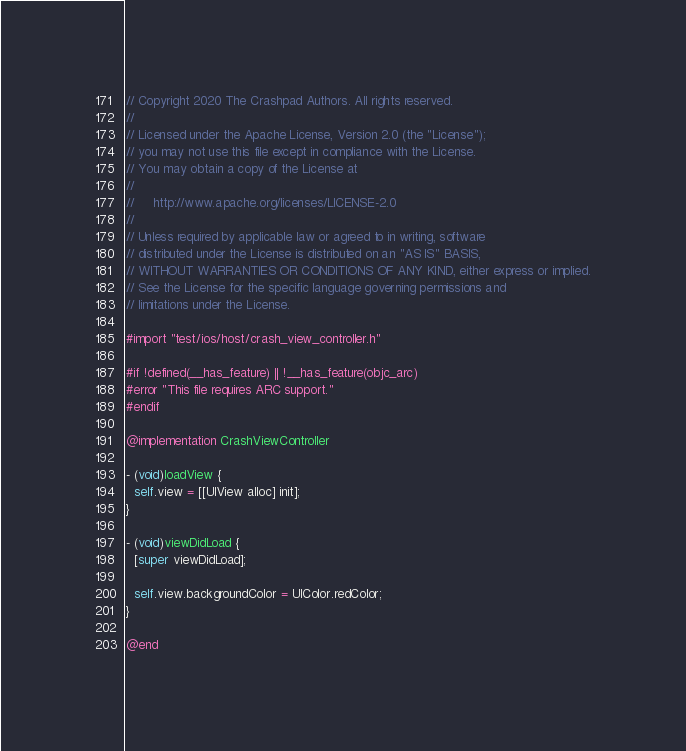<code> <loc_0><loc_0><loc_500><loc_500><_ObjectiveC_>// Copyright 2020 The Crashpad Authors. All rights reserved.
//
// Licensed under the Apache License, Version 2.0 (the "License");
// you may not use this file except in compliance with the License.
// You may obtain a copy of the License at
//
//     http://www.apache.org/licenses/LICENSE-2.0
//
// Unless required by applicable law or agreed to in writing, software
// distributed under the License is distributed on an "AS IS" BASIS,
// WITHOUT WARRANTIES OR CONDITIONS OF ANY KIND, either express or implied.
// See the License for the specific language governing permissions and
// limitations under the License.

#import "test/ios/host/crash_view_controller.h"

#if !defined(__has_feature) || !__has_feature(objc_arc)
#error "This file requires ARC support."
#endif

@implementation CrashViewController

- (void)loadView {
  self.view = [[UIView alloc] init];
}

- (void)viewDidLoad {
  [super viewDidLoad];

  self.view.backgroundColor = UIColor.redColor;
}

@end
</code> 